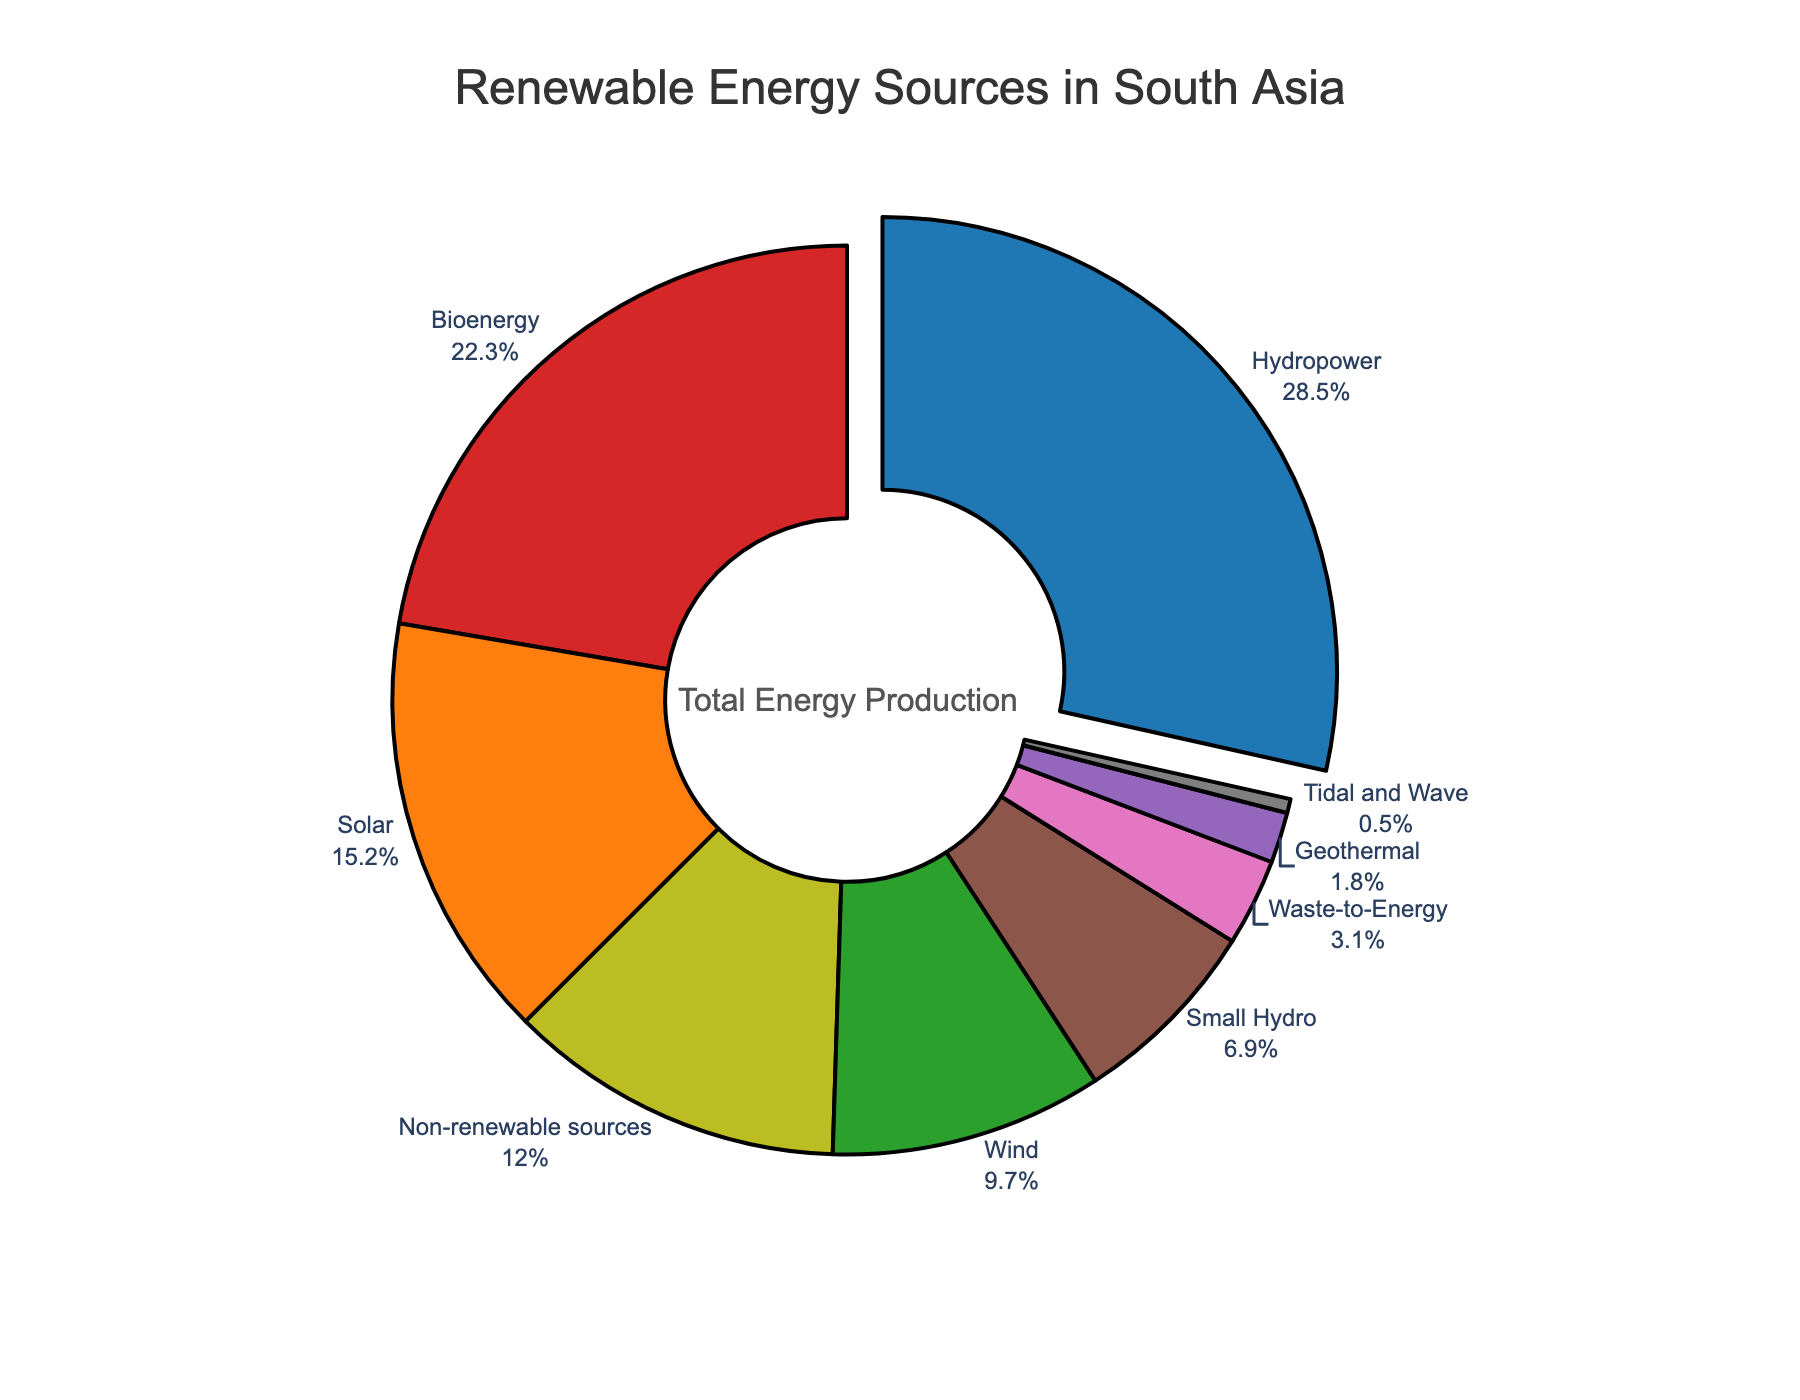What is the largest renewable energy source in South Asia in terms of share? The figure highlights the largest segment, which is pulled out for emphasis. This segment is for Hydropower.
Answer: Hydropower Which renewable energy source has the smallest share, and what is its percentage? The smallest segment in the chart corresponds to Tidal and Wave energy, which is listed with a share of 0.5%.
Answer: Tidal and Wave, 0.5% How much larger is the share of Solar energy compared to Wind energy? Solar energy has a share of 15.2%, and Wind energy has a share of 9.7%. The difference can be calculated as 15.2 - 9.7 = 5.5%.
Answer: 5.5% What are the combined shares of Bioenergy and Small Hydro? Bioenergy has a share of 22.3%, and Small Hydro has a share of 6.9%. The combined share is 22.3 + 6.9 = 29.2%.
Answer: 29.2% Which energy source has nearly one-tenth of the total pie share? Waste-to-Energy makes up 3.1%, which is the closest to one-tenth of 31% in the pie chart.
Answer: Waste-to-Energy Excluding non-renewable sources, which renewable energy source has the third largest share? Ignoring non-renewable sources, the top three renewable sources are Hydropower (28.5%), Bioenergy (22.3%), and Solar (15.2%). The third largest is Solar energy.
Answer: Solar What is the total share of energy sources other than Hydropower and Bioenergy? Exclude the shares of Hydropower (28.5%) and Bioenergy (22.3%) from 100%, then sum the shares of the remaining sources: 15.2 (Solar) + 9.7 (Wind) + 1.8 (Geothermal) + 6.9 (Small Hydro) + 3.1 (Waste-to-Energy) + 0.5 (Tidal and Wave) + 12.0 (Non-renewable) = 49.2%.
Answer: 49.2% What two renewable energy sources have a total share closest to Small Hydro's share? Small Hydro's share is 6.9%. The closest combination of two sources is Wind (9.7%) and Tidal and Wave (0.5%), which sum to 10.2%, but the closest lower sum to avoid exceeding is Solar (15.2%) and Tidal and Wave (0.5%), totaling 15.7%.
Answer: Solar and Small Hydro How does the cumulative share of Solar, Wind, and Geothermal compare to that of Hydropower? The shares are Solar (15.2%), Wind (9.7%), and Geothermal (1.8%), summing up to 26.7%. Hydropower has a share of 28.5%. Hydropower's share is slightly larger by 28.5 - 26.7 = 1.8%.
Answer: Hydropower is larger by 1.8% 